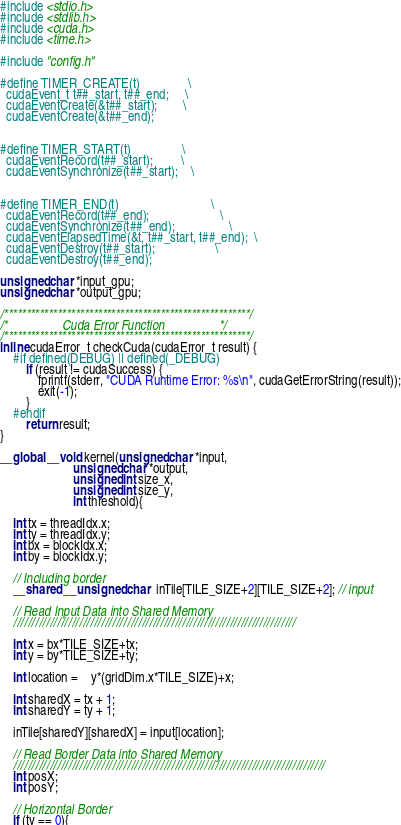Convert code to text. <code><loc_0><loc_0><loc_500><loc_500><_Cuda_>
#include <stdio.h>
#include <stdlib.h>
#include <cuda.h>
#include <time.h>

#include "config.h"

#define TIMER_CREATE(t)               \
  cudaEvent_t t##_start, t##_end;     \
  cudaEventCreate(&t##_start);        \
  cudaEventCreate(&t##_end);               
 
 
#define TIMER_START(t)                \
  cudaEventRecord(t##_start);         \
  cudaEventSynchronize(t##_start);    \
 
 
#define TIMER_END(t)                             \
  cudaEventRecord(t##_end);                      \
  cudaEventSynchronize(t##_end);                 \
  cudaEventElapsedTime(&t, t##_start, t##_end);  \
  cudaEventDestroy(t##_start);                   \
  cudaEventDestroy(t##_end);     
  
unsigned char *input_gpu;
unsigned char *output_gpu;

/*******************************************************/
/*                 Cuda Error Function                 */
/*******************************************************/
inline cudaError_t checkCuda(cudaError_t result) {
	#if defined(DEBUG) || defined(_DEBUG)
		if (result != cudaSuccess) {
			fprintf(stderr, "CUDA Runtime Error: %s\n", cudaGetErrorString(result));
			exit(-1);
		}
	#endif
		return result;
}

__global__ void kernel(unsigned char *input, 
                       unsigned char *output,
                       unsigned int size_x,
                       unsigned int size_y,
                       int threshold){

	int tx = threadIdx.x;
	int ty = threadIdx.y;
	int bx = blockIdx.x;
	int by = blockIdx.y;
		
	// Including border
	__shared__ unsigned char  inTile[TILE_SIZE+2][TILE_SIZE+2]; // input

	// Read Input Data into Shared Memory
	/////////////////////////////////////////////////////////////////////////////

	int x = bx*TILE_SIZE+tx;
	int y = by*TILE_SIZE+ty;
	  
	int location = 	y*(gridDim.x*TILE_SIZE)+x;
	
	int sharedX = tx + 1;
	int sharedY = ty + 1;
		
	inTile[sharedY][sharedX] = input[location];

	// Read Border Data into Shared Memory
	/////////////////////////////////////////////////////////////////////////////////////
	int posX;
	int posY;
	
	// Horizontal Border
	if (ty == 0){</code> 